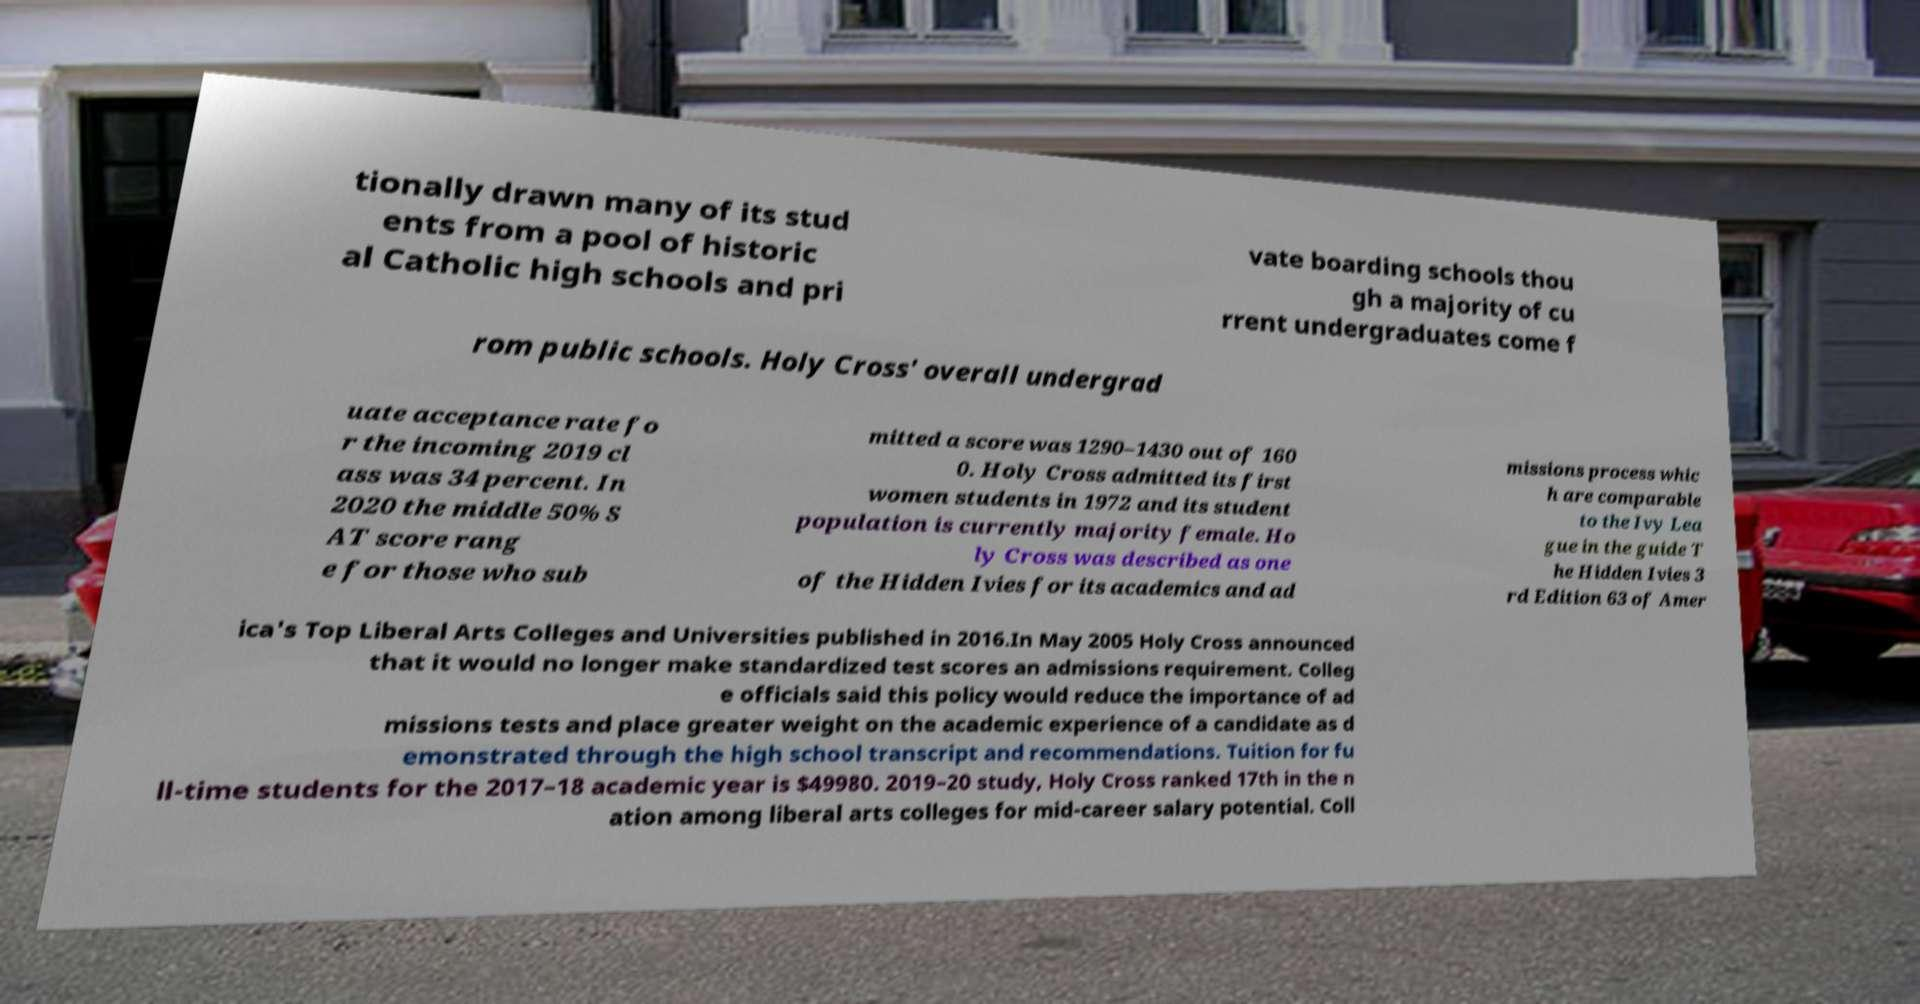Could you extract and type out the text from this image? tionally drawn many of its stud ents from a pool of historic al Catholic high schools and pri vate boarding schools thou gh a majority of cu rrent undergraduates come f rom public schools. Holy Cross' overall undergrad uate acceptance rate fo r the incoming 2019 cl ass was 34 percent. In 2020 the middle 50% S AT score rang e for those who sub mitted a score was 1290–1430 out of 160 0. Holy Cross admitted its first women students in 1972 and its student population is currently majority female. Ho ly Cross was described as one of the Hidden Ivies for its academics and ad missions process whic h are comparable to the Ivy Lea gue in the guide T he Hidden Ivies 3 rd Edition 63 of Amer ica's Top Liberal Arts Colleges and Universities published in 2016.In May 2005 Holy Cross announced that it would no longer make standardized test scores an admissions requirement. Colleg e officials said this policy would reduce the importance of ad missions tests and place greater weight on the academic experience of a candidate as d emonstrated through the high school transcript and recommendations. Tuition for fu ll-time students for the 2017–18 academic year is $49980. 2019–20 study, Holy Cross ranked 17th in the n ation among liberal arts colleges for mid-career salary potential. Coll 